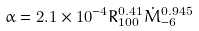Convert formula to latex. <formula><loc_0><loc_0><loc_500><loc_500>\alpha = 2 . 1 \times 1 0 ^ { - 4 } R _ { 1 0 0 } ^ { 0 . 4 1 } \dot { M } _ { - 6 } ^ { 0 . 9 4 5 }</formula> 